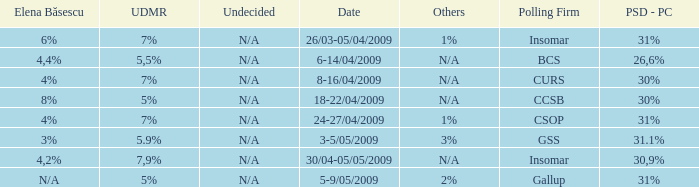When the other is n/a and the psc-pc is 30% what is the date? 8-16/04/2009, 18-22/04/2009. 